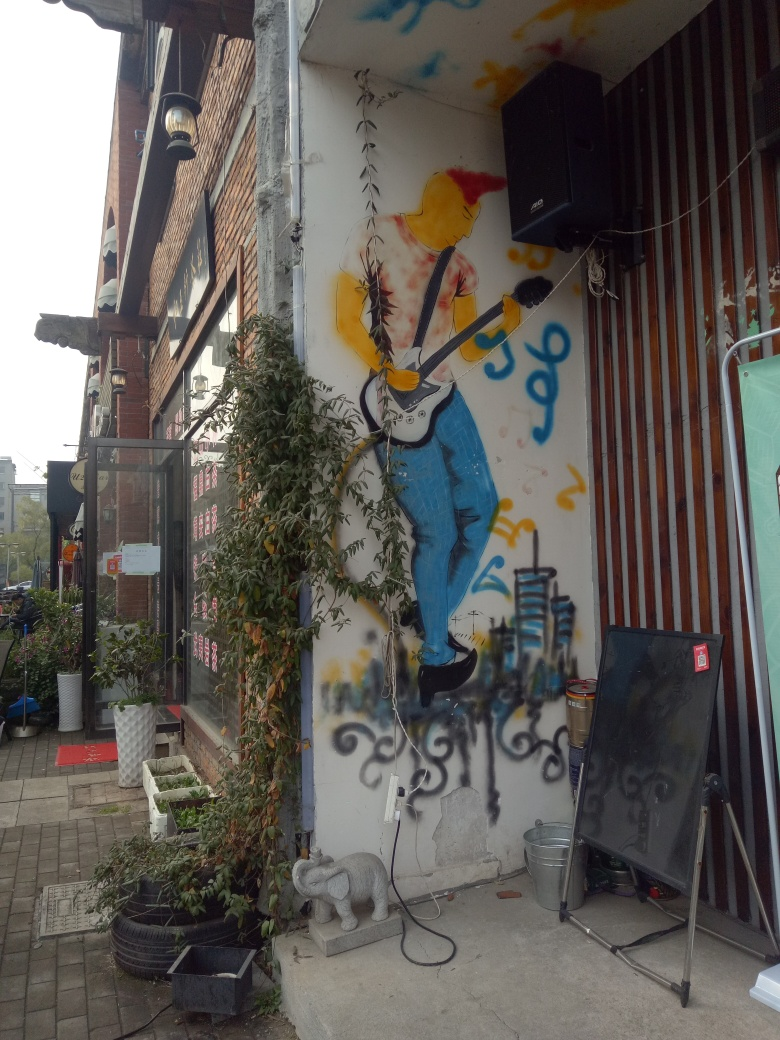Can you describe the setting around the mural? The mural is set on the side of a building with a mix of urban elements around it. There's a speaker mounted above the mural, a variety of potted plants below, and some items like a signboard and buckets suggesting a casual, possibly commercial, space. The scene suggests that this is a place where people might gather, perhaps to enjoy music or other street performances. 